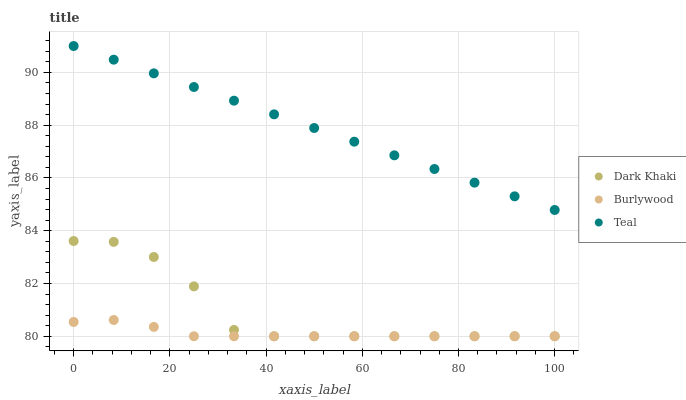Does Burlywood have the minimum area under the curve?
Answer yes or no. Yes. Does Teal have the maximum area under the curve?
Answer yes or no. Yes. Does Teal have the minimum area under the curve?
Answer yes or no. No. Does Burlywood have the maximum area under the curve?
Answer yes or no. No. Is Teal the smoothest?
Answer yes or no. Yes. Is Dark Khaki the roughest?
Answer yes or no. Yes. Is Burlywood the smoothest?
Answer yes or no. No. Is Burlywood the roughest?
Answer yes or no. No. Does Dark Khaki have the lowest value?
Answer yes or no. Yes. Does Teal have the lowest value?
Answer yes or no. No. Does Teal have the highest value?
Answer yes or no. Yes. Does Burlywood have the highest value?
Answer yes or no. No. Is Dark Khaki less than Teal?
Answer yes or no. Yes. Is Teal greater than Dark Khaki?
Answer yes or no. Yes. Does Burlywood intersect Dark Khaki?
Answer yes or no. Yes. Is Burlywood less than Dark Khaki?
Answer yes or no. No. Is Burlywood greater than Dark Khaki?
Answer yes or no. No. Does Dark Khaki intersect Teal?
Answer yes or no. No. 